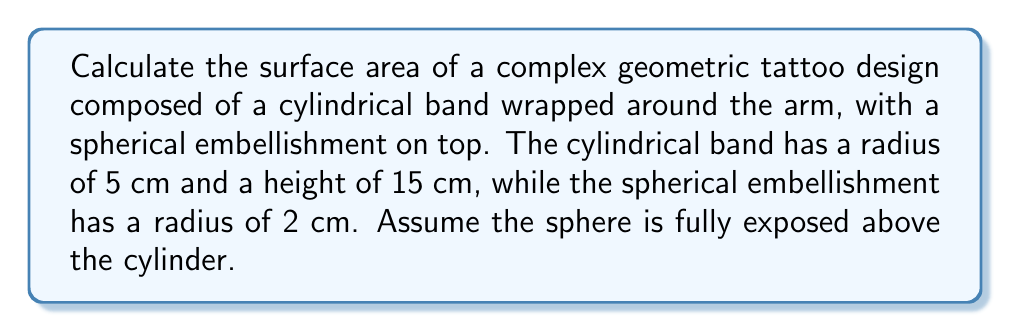Show me your answer to this math problem. Let's break this down step-by-step:

1. Calculate the surface area of the cylinder (excluding top and bottom):
   $$A_{cylinder} = 2\pi rh$$
   Where $r$ is the radius and $h$ is the height
   $$A_{cylinder} = 2\pi(5\text{ cm})(15\text{ cm}) = 150\pi\text{ cm}^2$$

2. Calculate the surface area of the sphere:
   $$A_{sphere} = 4\pi r^2$$
   Where $r$ is the radius of the sphere
   $$A_{sphere} = 4\pi(2\text{ cm})^2 = 16\pi\text{ cm}^2$$

3. Calculate the area of the circular top of the cylinder:
   $$A_{top} = \pi r^2$$
   $$A_{top} = \pi(5\text{ cm})^2 = 25\pi\text{ cm}^2$$

4. Subtract the area where the sphere intersects with the cylinder:
   $$A_{intersection} = \pi r^2$$
   Where $r$ is the radius of the sphere
   $$A_{intersection} = \pi(2\text{ cm})^2 = 4\pi\text{ cm}^2$$

5. Sum up all the areas:
   $$A_{total} = A_{cylinder} + A_{sphere} + A_{top} - A_{intersection}$$
   $$A_{total} = 150\pi\text{ cm}^2 + 16\pi\text{ cm}^2 + 25\pi\text{ cm}^2 - 4\pi\text{ cm}^2$$
   $$A_{total} = 187\pi\text{ cm}^2$$

[asy]
import geometry;

size(200);
real r = 5;
real h = 15;
real rs = 2;

path p = (0,0)--(0,h)--(r,h)--(r,0)--cycle;
path c = arc((0,h),rs,0,180);

fill(p,lightgray);
draw(p);
draw((0,0)--(0,h));
draw((r,0)--(r,h));
draw(arc((0,0),r,0,180),dashed);
draw(arc((0,h),r,0,180));
draw(c);

label("5 cm",(-0.5,h/2),W);
label("15 cm",(r+0.5,h/2),E);
label("2 cm",(rs/2,h+rs+0.5),N);
[/asy]
Answer: $187\pi\text{ cm}^2$ 